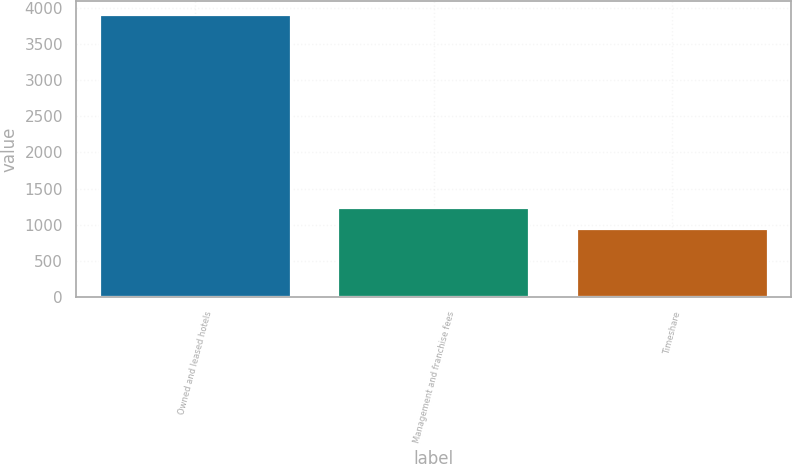Convert chart to OTSL. <chart><loc_0><loc_0><loc_500><loc_500><bar_chart><fcel>Owned and leased hotels<fcel>Management and franchise fees<fcel>Timeshare<nl><fcel>3898<fcel>1239.4<fcel>944<nl></chart> 